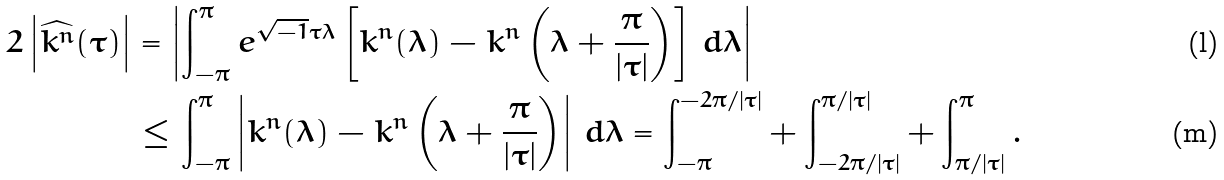Convert formula to latex. <formula><loc_0><loc_0><loc_500><loc_500>2 \left | \widehat { k ^ { n } } ( \tau ) \right | & = \left | \int _ { - \pi } ^ { \pi } e ^ { \sqrt { - 1 } \tau \lambda } \left [ k ^ { n } ( \lambda ) - k ^ { n } \left ( \lambda + \frac { \pi } { | \tau | } \right ) \right ] \, d \lambda \right | \\ & \leq \int _ { - \pi } ^ { \pi } \left | k ^ { n } ( \lambda ) - k ^ { n } \left ( \lambda + \frac { \pi } { | \tau | } \right ) \right | \, d \lambda = \int _ { - \pi } ^ { - 2 \pi / | \tau | } + \int _ { - 2 \pi / | \tau | } ^ { \pi / | \tau | } + \int _ { \pi / | \tau | } ^ { \pi } .</formula> 